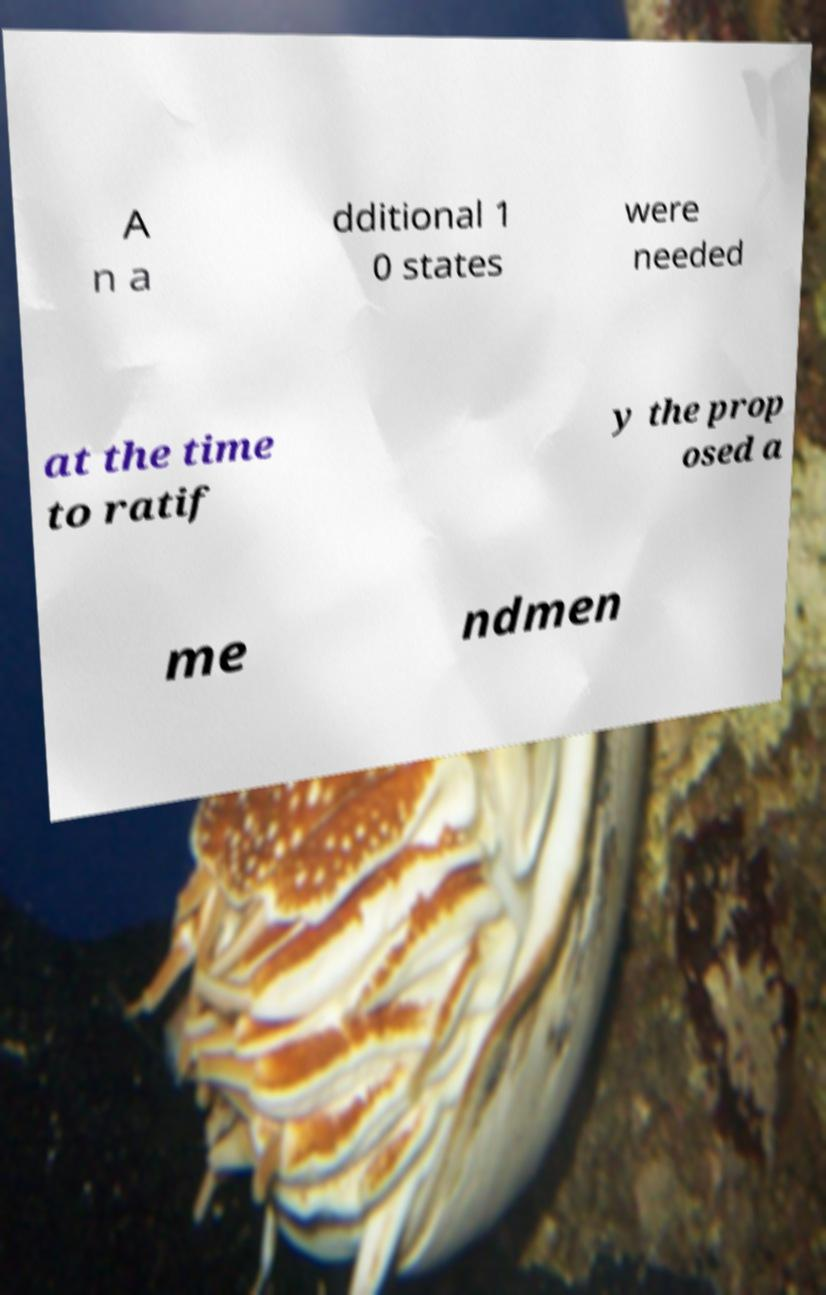What messages or text are displayed in this image? I need them in a readable, typed format. A n a dditional 1 0 states were needed at the time to ratif y the prop osed a me ndmen 